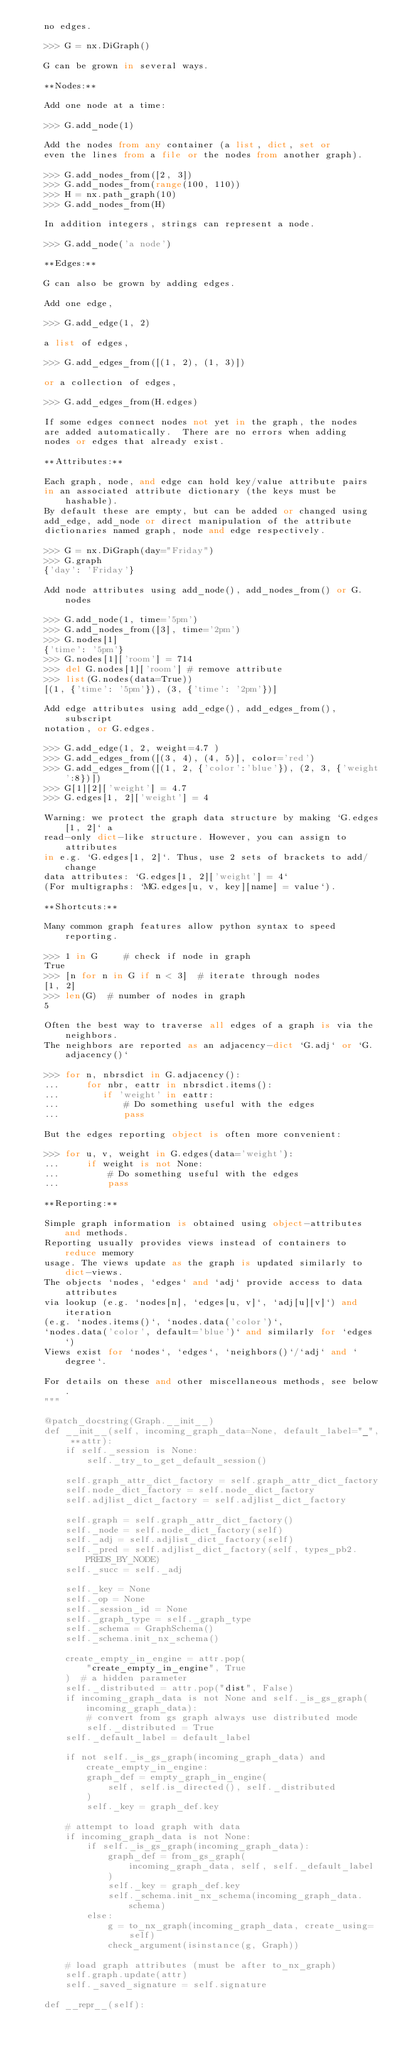<code> <loc_0><loc_0><loc_500><loc_500><_Python_>    no edges.

    >>> G = nx.DiGraph()

    G can be grown in several ways.

    **Nodes:**

    Add one node at a time:

    >>> G.add_node(1)

    Add the nodes from any container (a list, dict, set or
    even the lines from a file or the nodes from another graph).

    >>> G.add_nodes_from([2, 3])
    >>> G.add_nodes_from(range(100, 110))
    >>> H = nx.path_graph(10)
    >>> G.add_nodes_from(H)

    In addition integers, strings can represent a node.

    >>> G.add_node('a node')

    **Edges:**

    G can also be grown by adding edges.

    Add one edge,

    >>> G.add_edge(1, 2)

    a list of edges,

    >>> G.add_edges_from([(1, 2), (1, 3)])

    or a collection of edges,

    >>> G.add_edges_from(H.edges)

    If some edges connect nodes not yet in the graph, the nodes
    are added automatically.  There are no errors when adding
    nodes or edges that already exist.

    **Attributes:**

    Each graph, node, and edge can hold key/value attribute pairs
    in an associated attribute dictionary (the keys must be hashable).
    By default these are empty, but can be added or changed using
    add_edge, add_node or direct manipulation of the attribute
    dictionaries named graph, node and edge respectively.

    >>> G = nx.DiGraph(day="Friday")
    >>> G.graph
    {'day': 'Friday'}

    Add node attributes using add_node(), add_nodes_from() or G.nodes

    >>> G.add_node(1, time='5pm')
    >>> G.add_nodes_from([3], time='2pm')
    >>> G.nodes[1]
    {'time': '5pm'}
    >>> G.nodes[1]['room'] = 714
    >>> del G.nodes[1]['room'] # remove attribute
    >>> list(G.nodes(data=True))
    [(1, {'time': '5pm'}), (3, {'time': '2pm'})]

    Add edge attributes using add_edge(), add_edges_from(), subscript
    notation, or G.edges.

    >>> G.add_edge(1, 2, weight=4.7 )
    >>> G.add_edges_from([(3, 4), (4, 5)], color='red')
    >>> G.add_edges_from([(1, 2, {'color':'blue'}), (2, 3, {'weight':8})])
    >>> G[1][2]['weight'] = 4.7
    >>> G.edges[1, 2]['weight'] = 4

    Warning: we protect the graph data structure by making `G.edges[1, 2]` a
    read-only dict-like structure. However, you can assign to attributes
    in e.g. `G.edges[1, 2]`. Thus, use 2 sets of brackets to add/change
    data attributes: `G.edges[1, 2]['weight'] = 4`
    (For multigraphs: `MG.edges[u, v, key][name] = value`).

    **Shortcuts:**

    Many common graph features allow python syntax to speed reporting.

    >>> 1 in G     # check if node in graph
    True
    >>> [n for n in G if n < 3]  # iterate through nodes
    [1, 2]
    >>> len(G)  # number of nodes in graph
    5

    Often the best way to traverse all edges of a graph is via the neighbors.
    The neighbors are reported as an adjacency-dict `G.adj` or `G.adjacency()`

    >>> for n, nbrsdict in G.adjacency():
    ...     for nbr, eattr in nbrsdict.items():
    ...        if 'weight' in eattr:
    ...            # Do something useful with the edges
    ...            pass

    But the edges reporting object is often more convenient:

    >>> for u, v, weight in G.edges(data='weight'):
    ...     if weight is not None:
    ...         # Do something useful with the edges
    ...         pass

    **Reporting:**

    Simple graph information is obtained using object-attributes and methods.
    Reporting usually provides views instead of containers to reduce memory
    usage. The views update as the graph is updated similarly to dict-views.
    The objects `nodes, `edges` and `adj` provide access to data attributes
    via lookup (e.g. `nodes[n], `edges[u, v]`, `adj[u][v]`) and iteration
    (e.g. `nodes.items()`, `nodes.data('color')`,
    `nodes.data('color', default='blue')` and similarly for `edges`)
    Views exist for `nodes`, `edges`, `neighbors()`/`adj` and `degree`.

    For details on these and other miscellaneous methods, see below.
    """

    @patch_docstring(Graph.__init__)
    def __init__(self, incoming_graph_data=None, default_label="_", **attr):
        if self._session is None:
            self._try_to_get_default_session()

        self.graph_attr_dict_factory = self.graph_attr_dict_factory
        self.node_dict_factory = self.node_dict_factory
        self.adjlist_dict_factory = self.adjlist_dict_factory

        self.graph = self.graph_attr_dict_factory()
        self._node = self.node_dict_factory(self)
        self._adj = self.adjlist_dict_factory(self)
        self._pred = self.adjlist_dict_factory(self, types_pb2.PREDS_BY_NODE)
        self._succ = self._adj

        self._key = None
        self._op = None
        self._session_id = None
        self._graph_type = self._graph_type
        self._schema = GraphSchema()
        self._schema.init_nx_schema()

        create_empty_in_engine = attr.pop(
            "create_empty_in_engine", True
        )  # a hidden parameter
        self._distributed = attr.pop("dist", False)
        if incoming_graph_data is not None and self._is_gs_graph(incoming_graph_data):
            # convert from gs graph always use distributed mode
            self._distributed = True
        self._default_label = default_label

        if not self._is_gs_graph(incoming_graph_data) and create_empty_in_engine:
            graph_def = empty_graph_in_engine(
                self, self.is_directed(), self._distributed
            )
            self._key = graph_def.key

        # attempt to load graph with data
        if incoming_graph_data is not None:
            if self._is_gs_graph(incoming_graph_data):
                graph_def = from_gs_graph(
                    incoming_graph_data, self, self._default_label
                )
                self._key = graph_def.key
                self._schema.init_nx_schema(incoming_graph_data.schema)
            else:
                g = to_nx_graph(incoming_graph_data, create_using=self)
                check_argument(isinstance(g, Graph))

        # load graph attributes (must be after to_nx_graph)
        self.graph.update(attr)
        self._saved_signature = self.signature

    def __repr__(self):</code> 